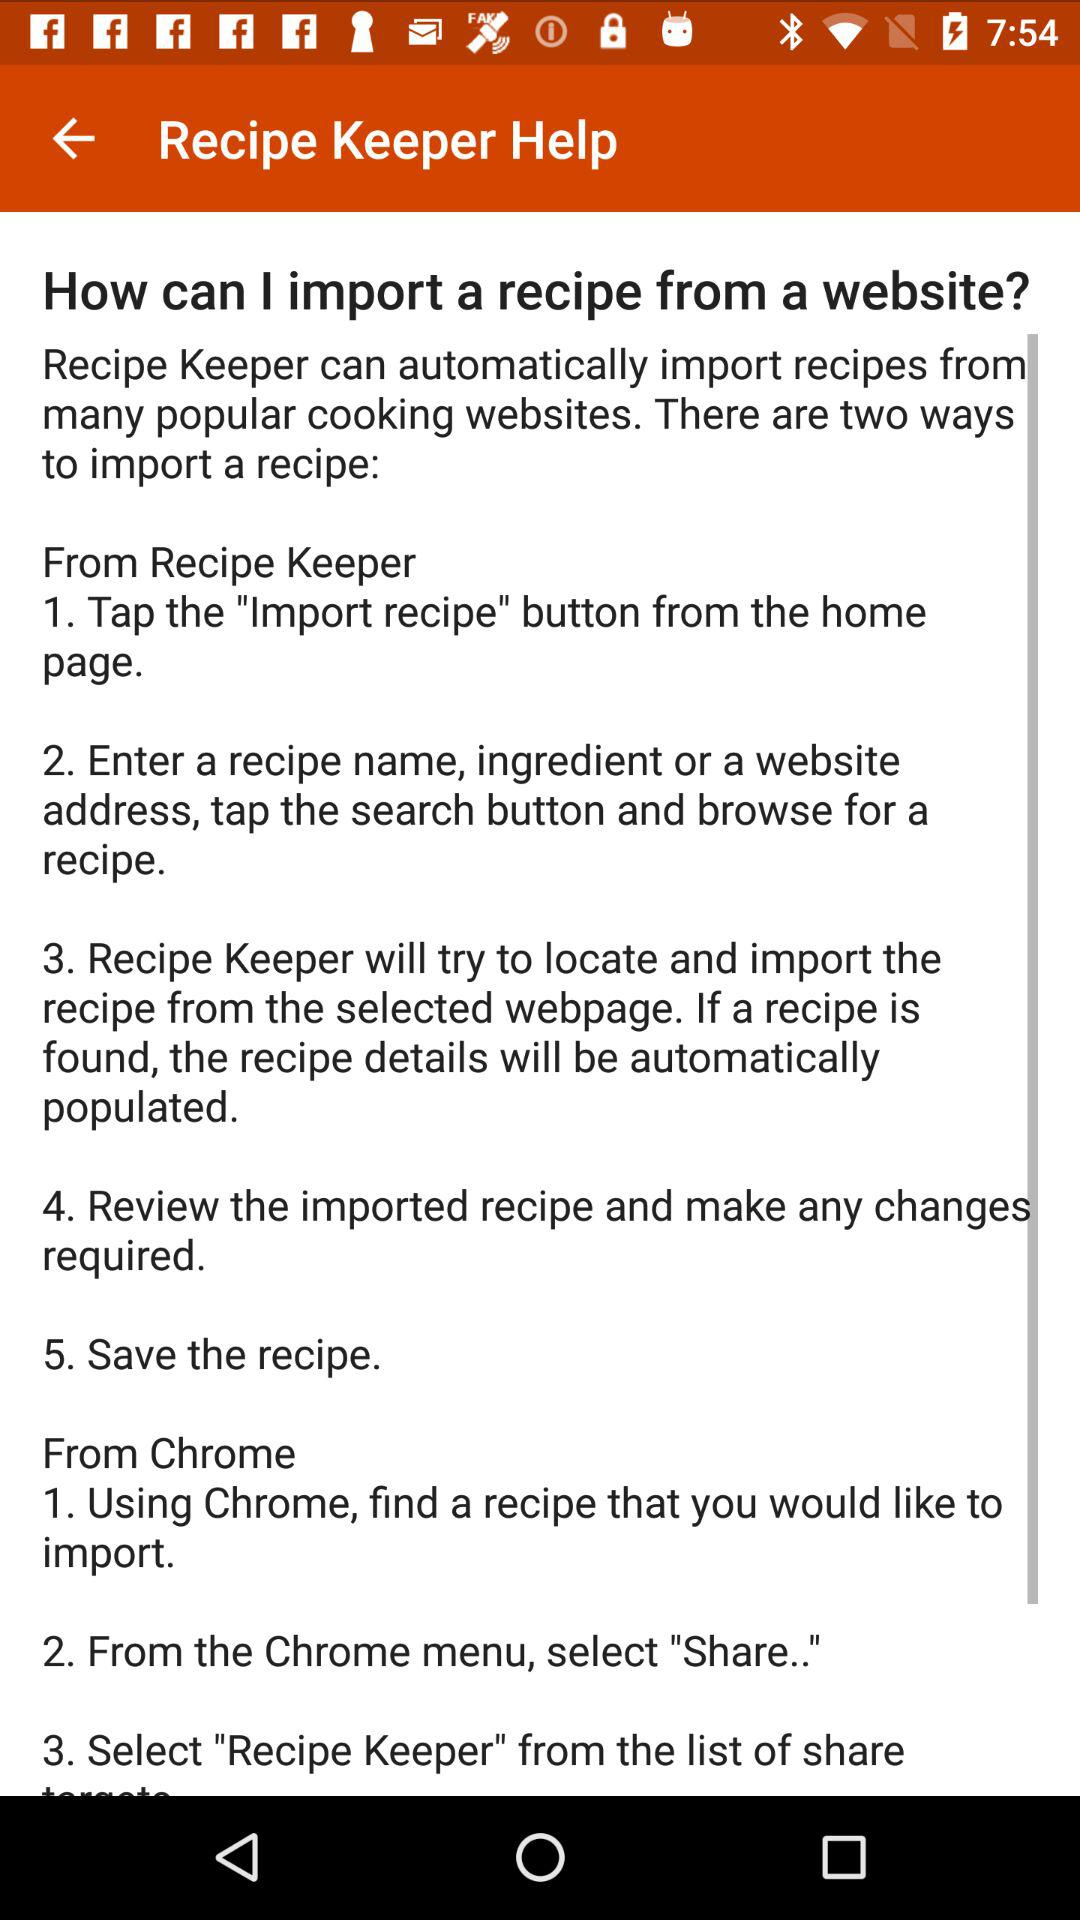How many steps are there to import a recipe from Recipe Keeper?
Answer the question using a single word or phrase. 5 